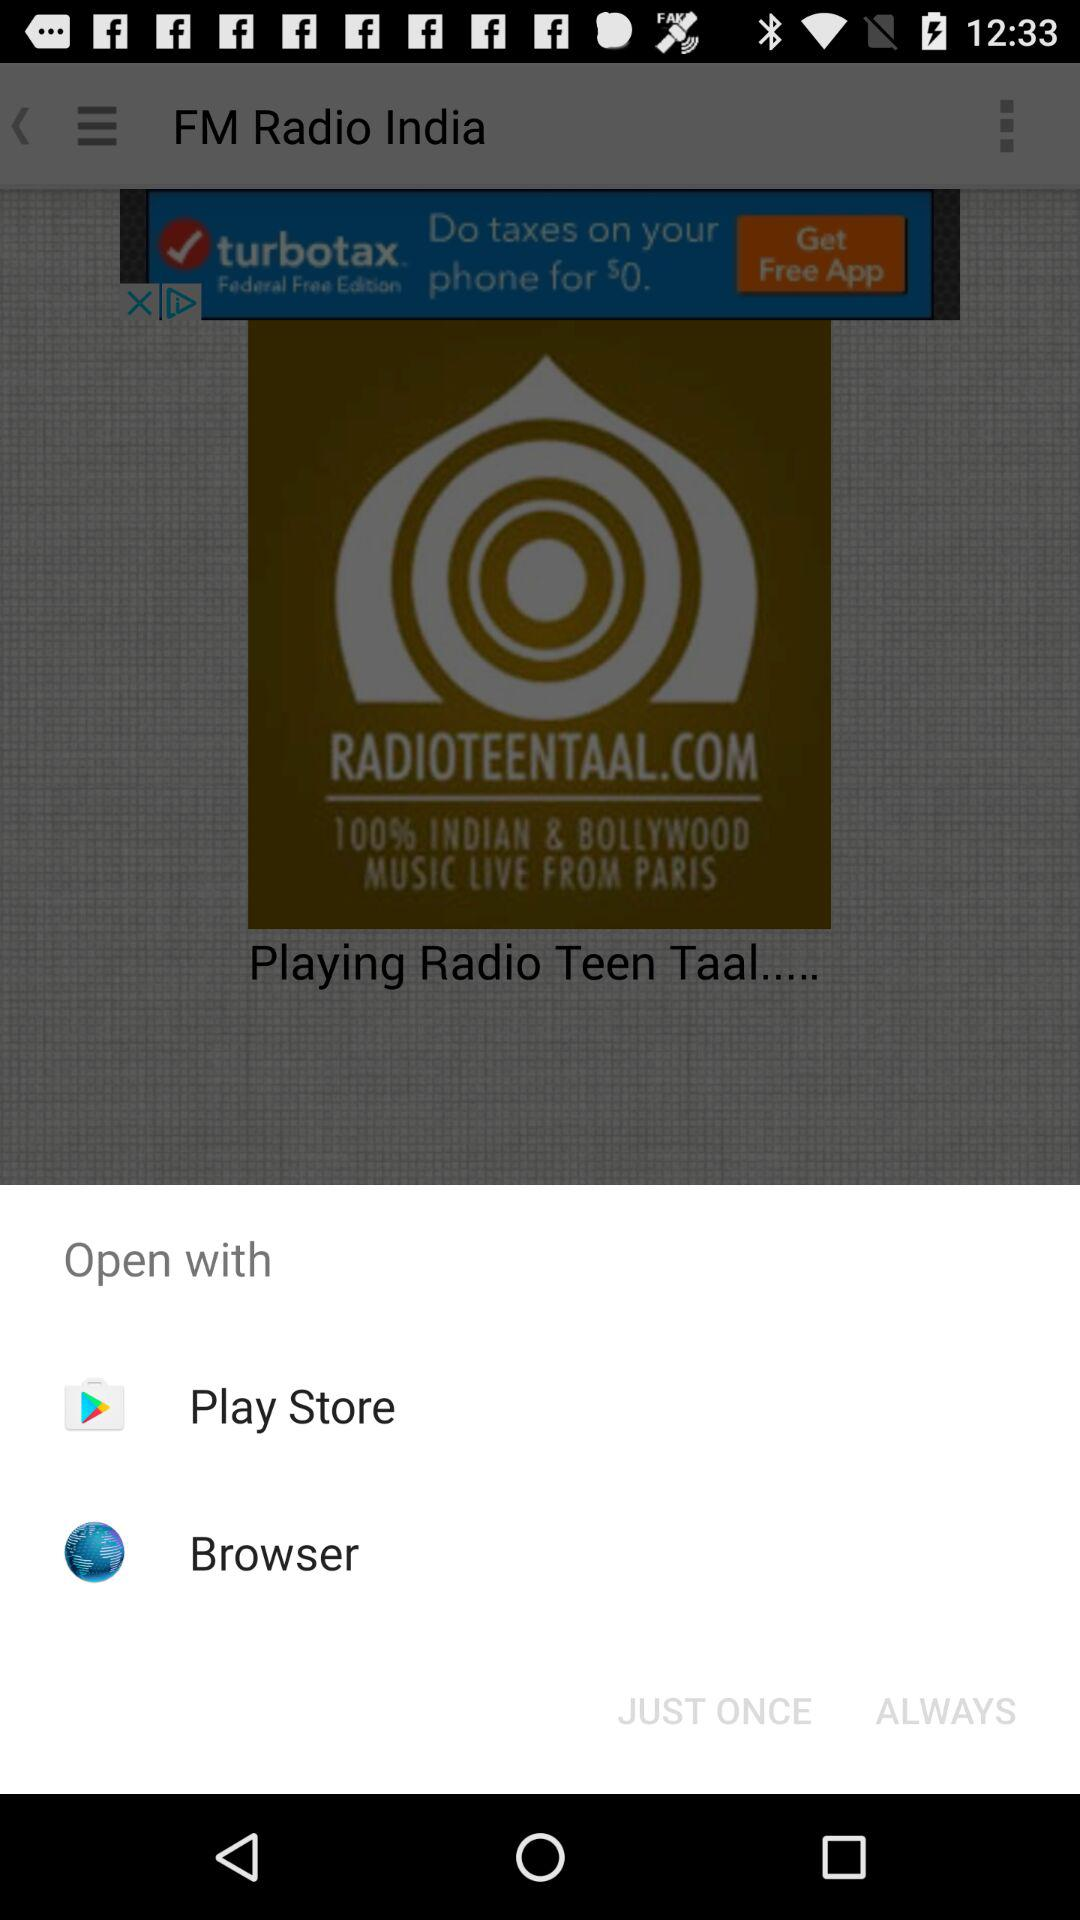Through what application can it be shared? It can be shared through "Play Store" and "Browser". 